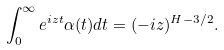Convert formula to latex. <formula><loc_0><loc_0><loc_500><loc_500>\int _ { 0 } ^ { \infty } e ^ { i z t } \alpha ( t ) d t = ( - i z ) ^ { H - 3 / 2 } .</formula> 